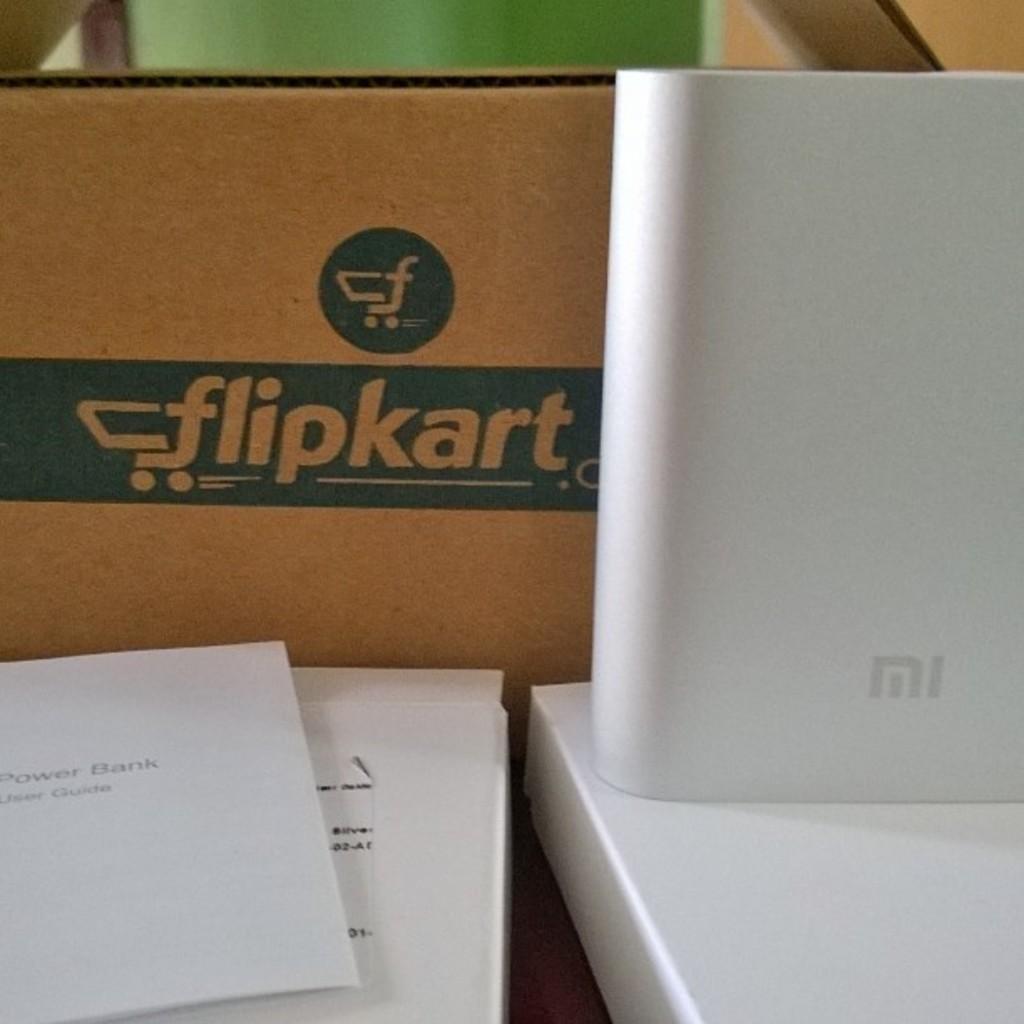Please provide a concise description of this image. In this image there are boxes, flipkart cardboard box and an MI power bank. 